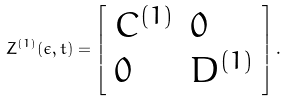Convert formula to latex. <formula><loc_0><loc_0><loc_500><loc_500>Z ^ { ( 1 ) } ( \epsilon , t ) = \left [ \begin{array} { l l } C ^ { ( 1 ) } & 0 \\ 0 & D ^ { ( 1 ) } \end{array} \right ] .</formula> 